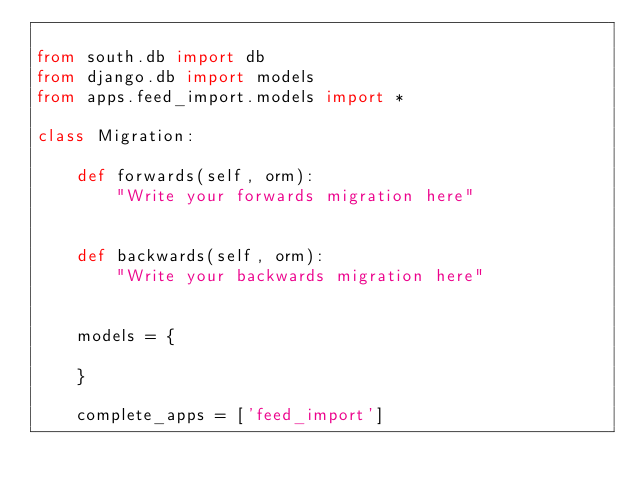Convert code to text. <code><loc_0><loc_0><loc_500><loc_500><_Python_>
from south.db import db
from django.db import models
from apps.feed_import.models import *

class Migration:
    
    def forwards(self, orm):
        "Write your forwards migration here"
    
    
    def backwards(self, orm):
        "Write your backwards migration here"
    
    
    models = {
        
    }
    
    complete_apps = ['feed_import']
</code> 